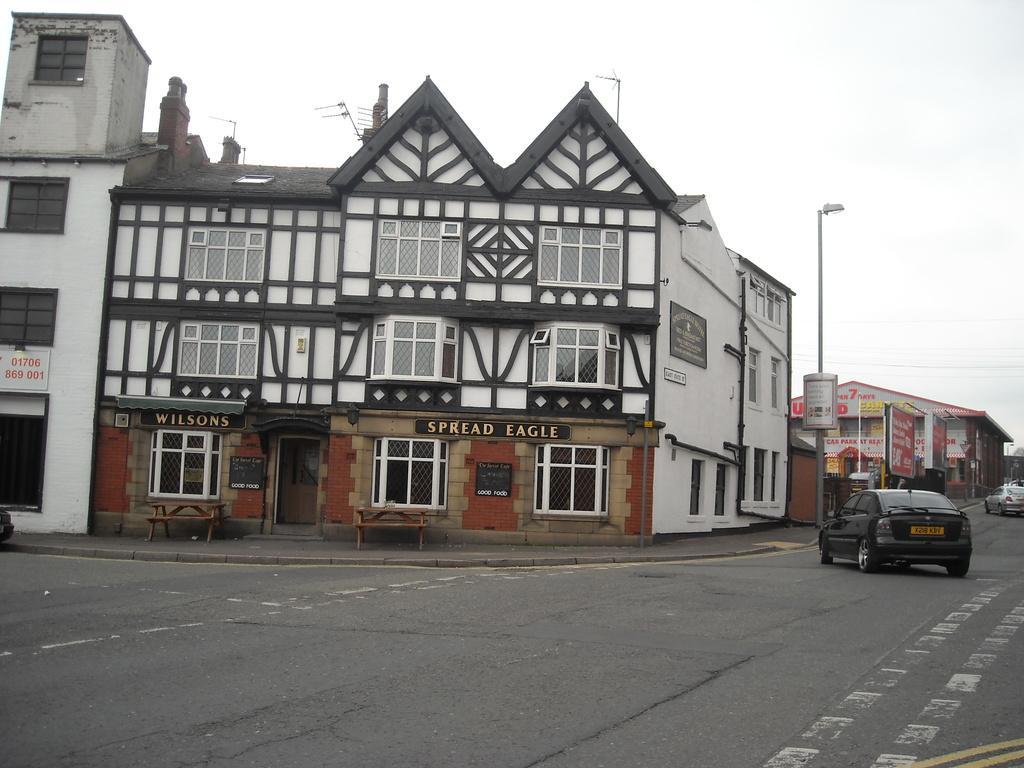Can you describe this image briefly? There are vehicles on the road. Here we can see buildings, windows, boards, and poles. In the background there is sky. 